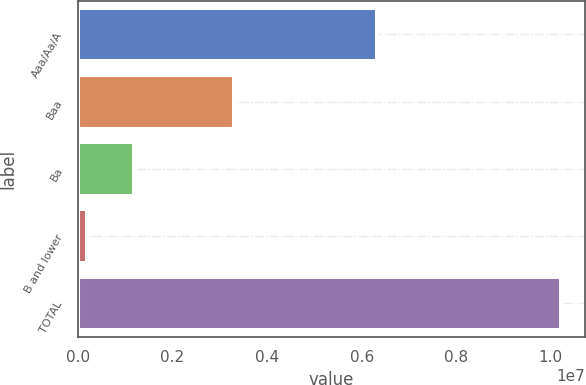<chart> <loc_0><loc_0><loc_500><loc_500><bar_chart><fcel>Aaa/Aa/A<fcel>Baa<fcel>Ba<fcel>B and lower<fcel>TOTAL<nl><fcel>6.3268e+06<fcel>3.30972e+06<fcel>1.19205e+06<fcel>189460<fcel>1.02153e+07<nl></chart> 